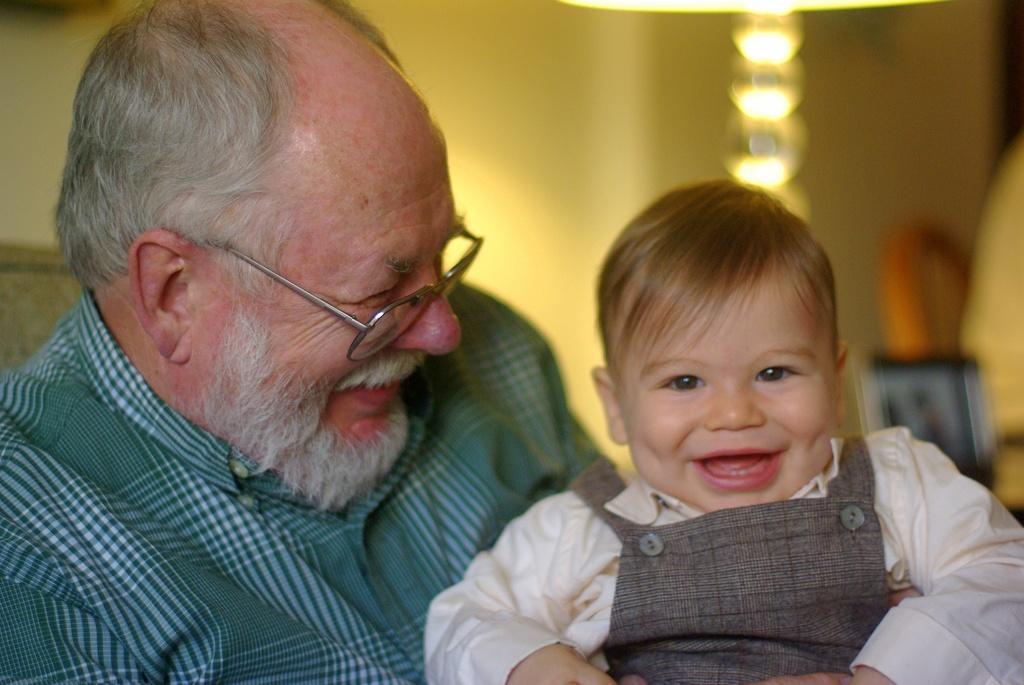Describe this image in one or two sentences. This picture is clicked inside the room. In the foreground we can see a man wearing shirt, smiling and seems to be sitting and we can see a kid smiling and seems to be sitting. In the background we can see the lights, wall and some other objects. 